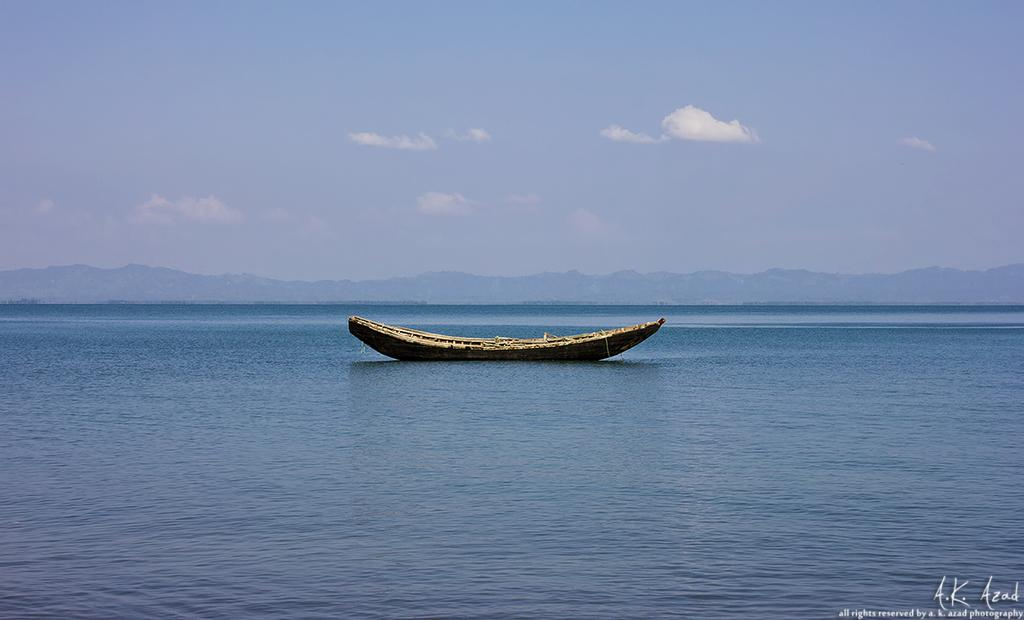What is the main subject of the image? The main subject of the image is a boat. Where is the boat located? The boat is on the sea. What can be seen in the background of the image? Mountains and clouds are visible in the image. What part of the sky is visible in the image? The sky is visible in the image. Is there any text present in the image? Yes, there is text on the image. How many planes are flying over the boat in the image? There are no planes visible in the image; it only features a boat on the sea with mountains, clouds, and sky in the background. 